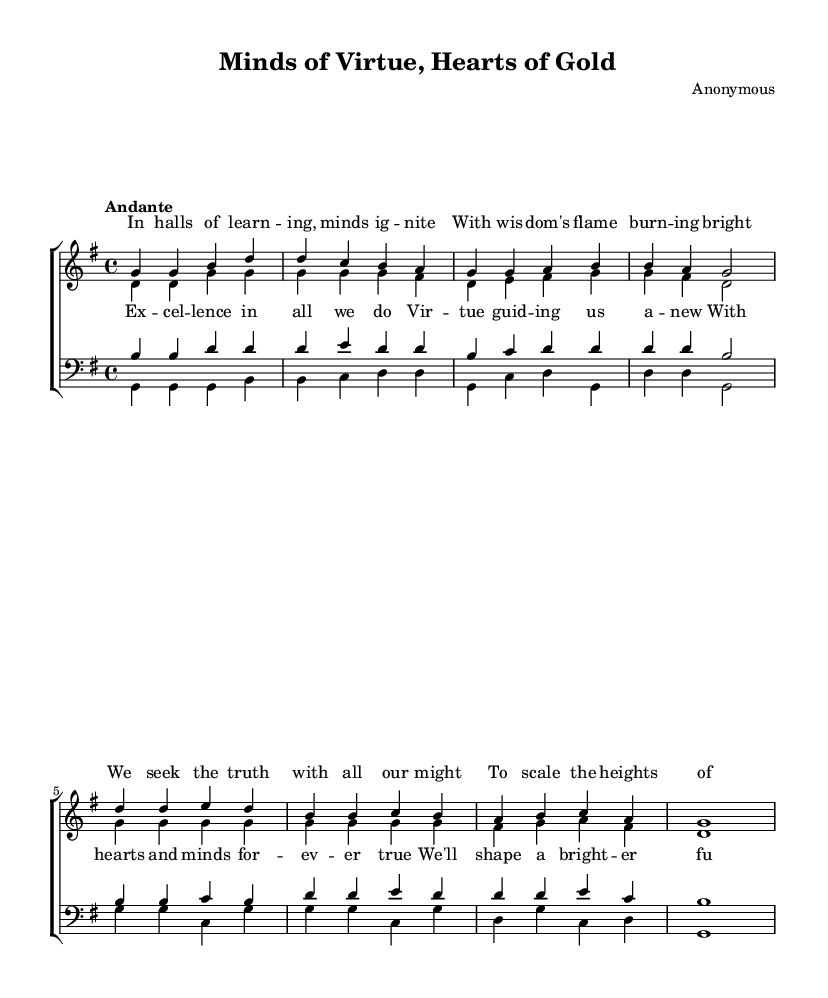What is the key signature of this music? The key signature is G major, indicated by one sharp (F#), which corresponds to the beginning of the music sheet.
Answer: G major What is the time signature of this music? The time signature is 4/4, as shown at the beginning of the sheet music, indicating that there are four beats in each measure.
Answer: 4/4 What is the tempo marking for this piece? The tempo marking is "Andante," which means moderately slow, and is typically associated with a walking pace. This is stated at the beginning of the score.
Answer: Andante How many verses are present in the piece? The piece contains one verse, as it is indicated clearly in the lyrics section with a distinct separation between the verses and the chorus.
Answer: One verse In which section does the word "Excellence" appear? The word "Excellence" appears in the chorus section, where the focus shifts to expressing the ideals of virtue and excellence in actions. The lyrics are clearly denoted under respective sections.
Answer: Chorus What is the overall theme of the hymn? The overall theme of the hymn emphasizes the pursuit of academic excellence and the importance of virtue and moral values in shaping a brighter future, as reflected in both the verses and the chorus.
Answer: Academic excellence and virtue How many vocal parts are in the score? There are four vocal parts in the score: soprano, alto, tenor, and bass, as indicated by the labeling of the staves for each vocal section.
Answer: Four parts 